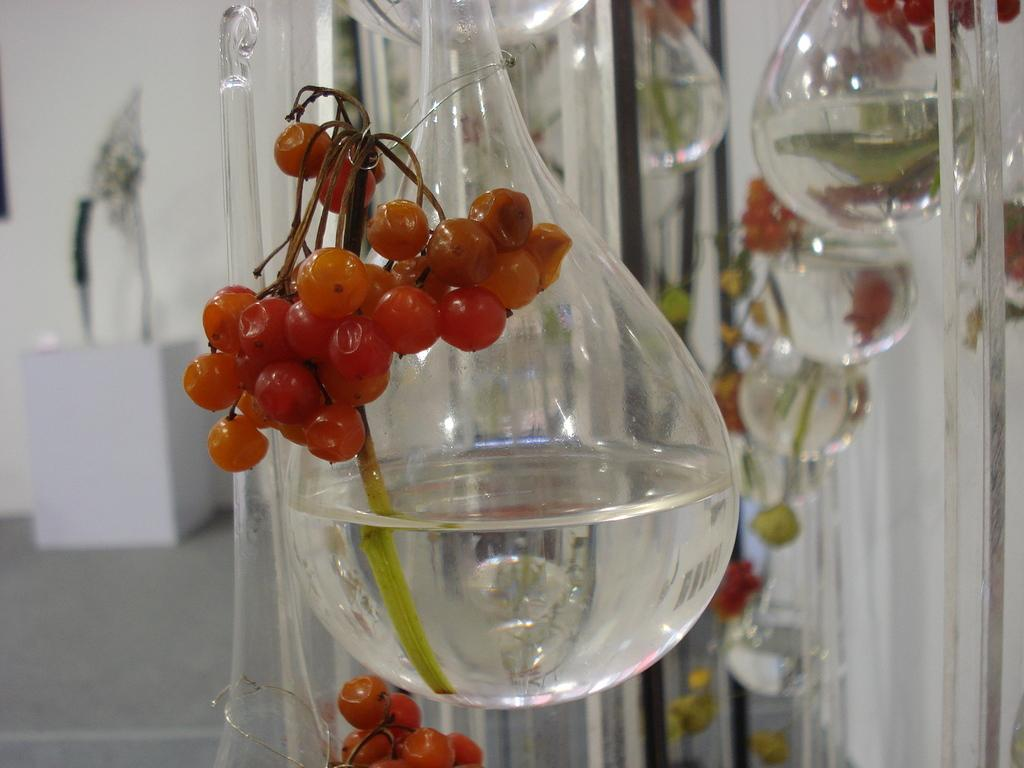What is in the glasses that are visible in the image? There are glasses with water in the image. What else can be seen inside the glasses? There are fruits in the glasses. What can be seen in the background of the image? There is a wall visible in the background of the image, and there are objects in the background as well. What type of swing can be seen in the image? There is no swing present in the image. Is there a lawyer visible in the image? There is no lawyer present in the image. 